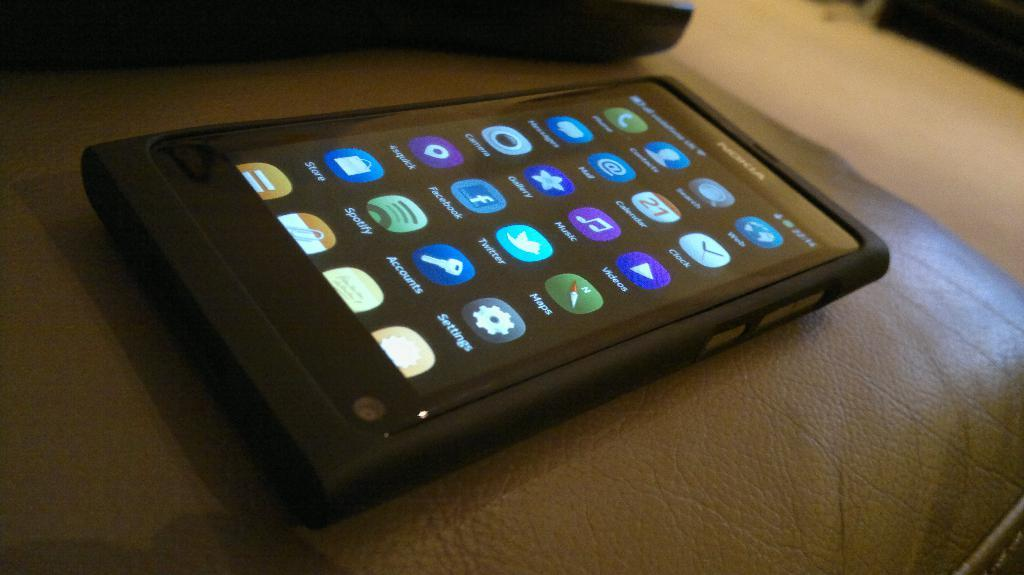<image>
Present a compact description of the photo's key features. Black phone with the app called Settings on the bottom right. 